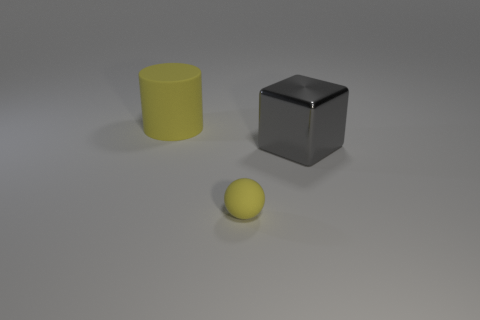What time of day does the lighting in the image suggest? The lighting in the image appears to be artificial, as indicated by the soft shadows with blurred edges. It doesn't seem to emulate any specific time of day but rather looks like controlled lighting typically used in a studio environment or for product photography. 